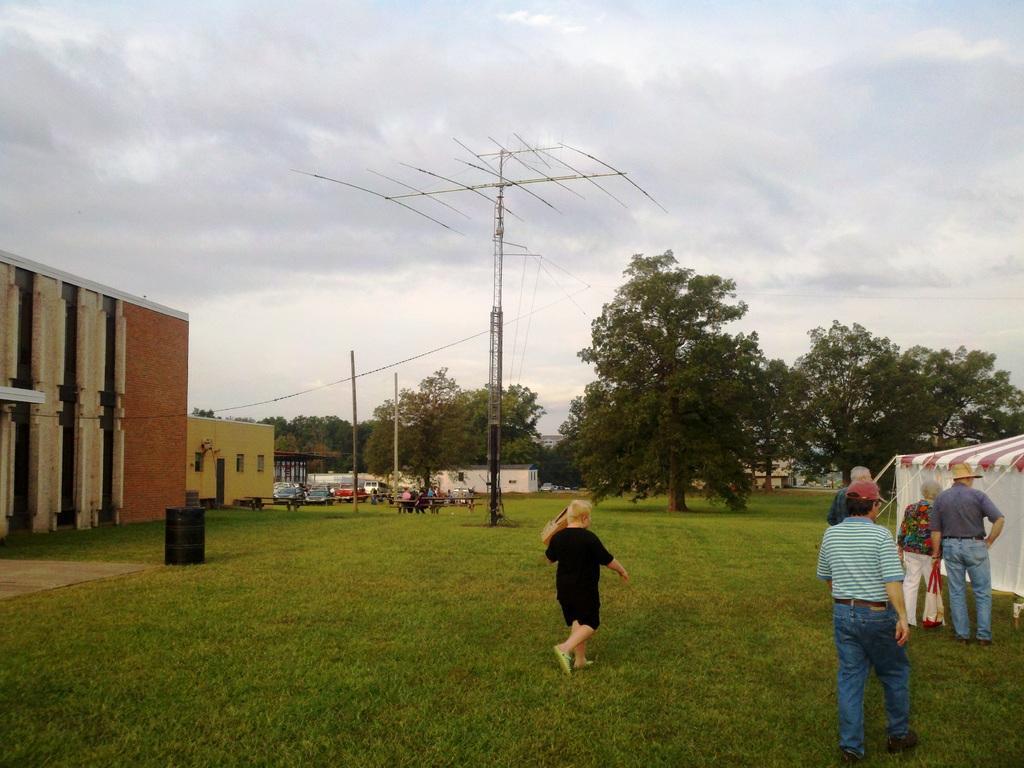Can you describe this image briefly? In the picture we can see a grass surface with some people standing and near to them, we can see a tent and in the background, we can see some antenna poles, trees, houses and sky with clouds. 